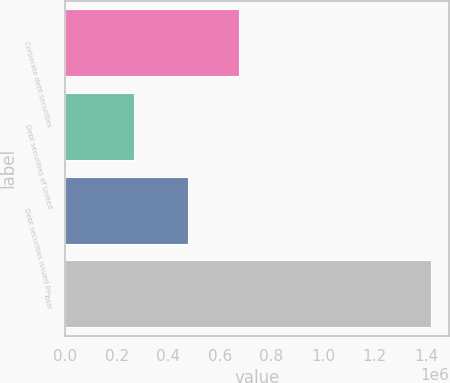Convert chart to OTSL. <chart><loc_0><loc_0><loc_500><loc_500><bar_chart><fcel>Corporate debt securities<fcel>Debt securities of United<fcel>Debt securities issued by<fcel>Total<nl><fcel>672554<fcel>266203<fcel>475024<fcel>1.41742e+06<nl></chart> 